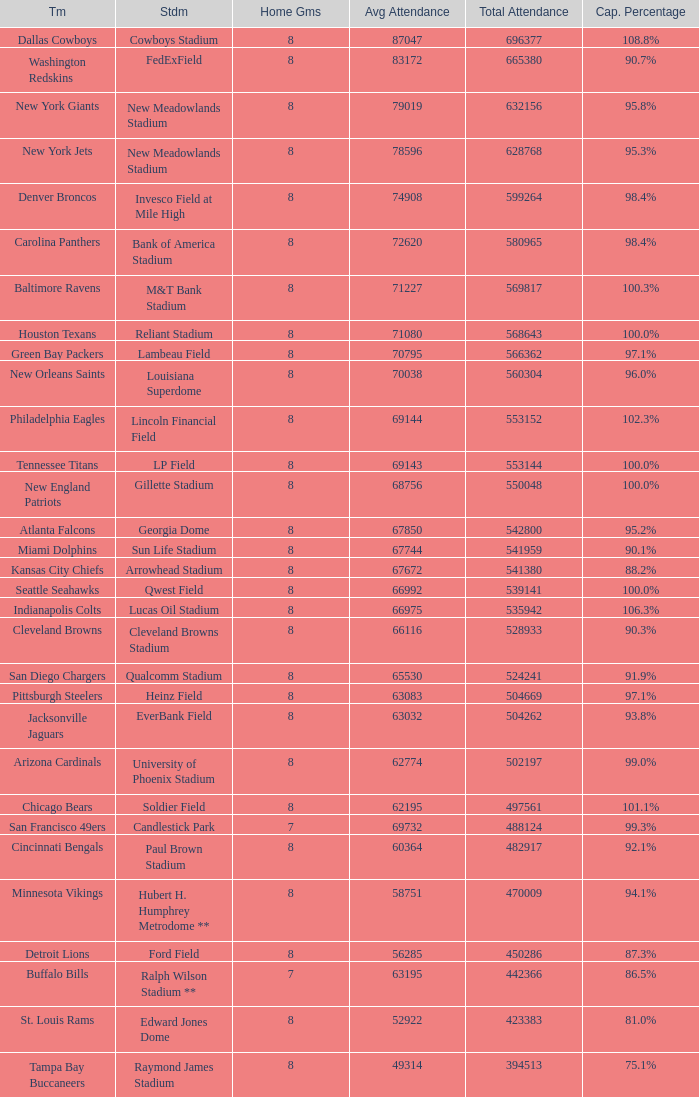What was average attendance when total attendance was 541380? 67672.0. 